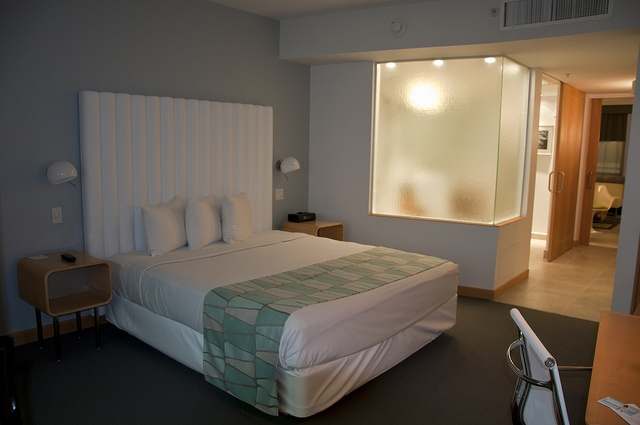Describe the objects in this image and their specific colors. I can see bed in black, gray, and teal tones, chair in black, gray, and darkgray tones, dining table in black, brown, maroon, and gray tones, clock in black and gray tones, and remote in black tones in this image. 